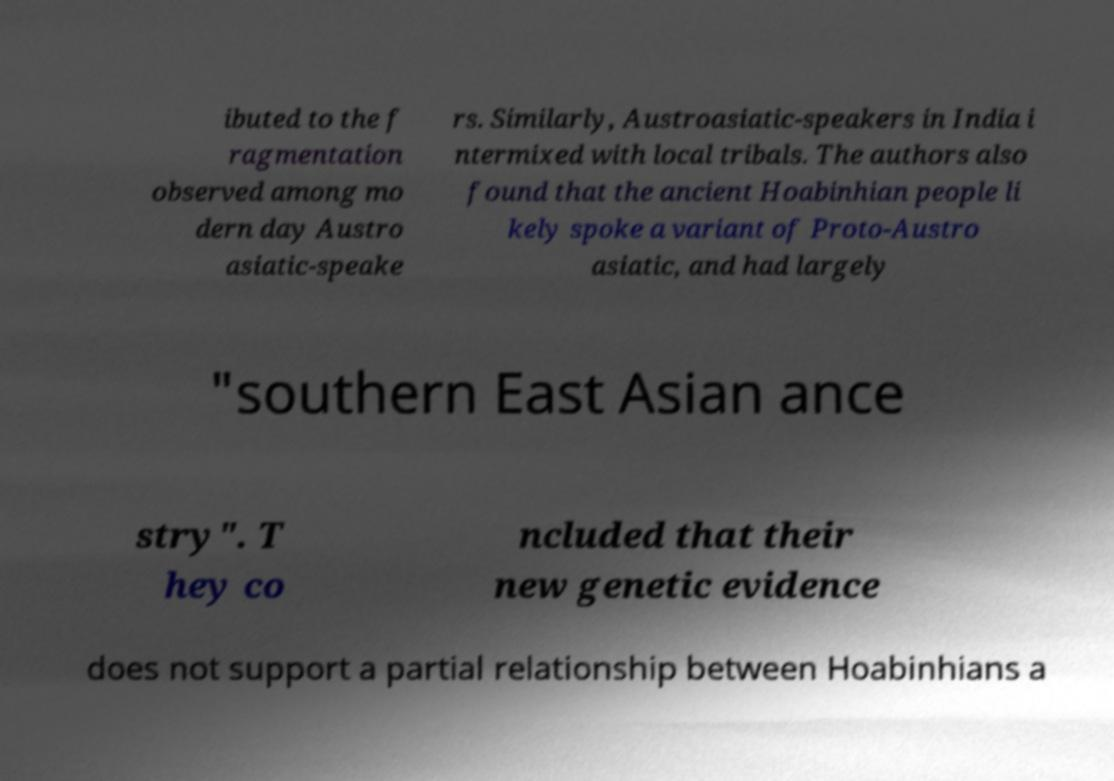Could you extract and type out the text from this image? ibuted to the f ragmentation observed among mo dern day Austro asiatic-speake rs. Similarly, Austroasiatic-speakers in India i ntermixed with local tribals. The authors also found that the ancient Hoabinhian people li kely spoke a variant of Proto-Austro asiatic, and had largely "southern East Asian ance stry". T hey co ncluded that their new genetic evidence does not support a partial relationship between Hoabinhians a 